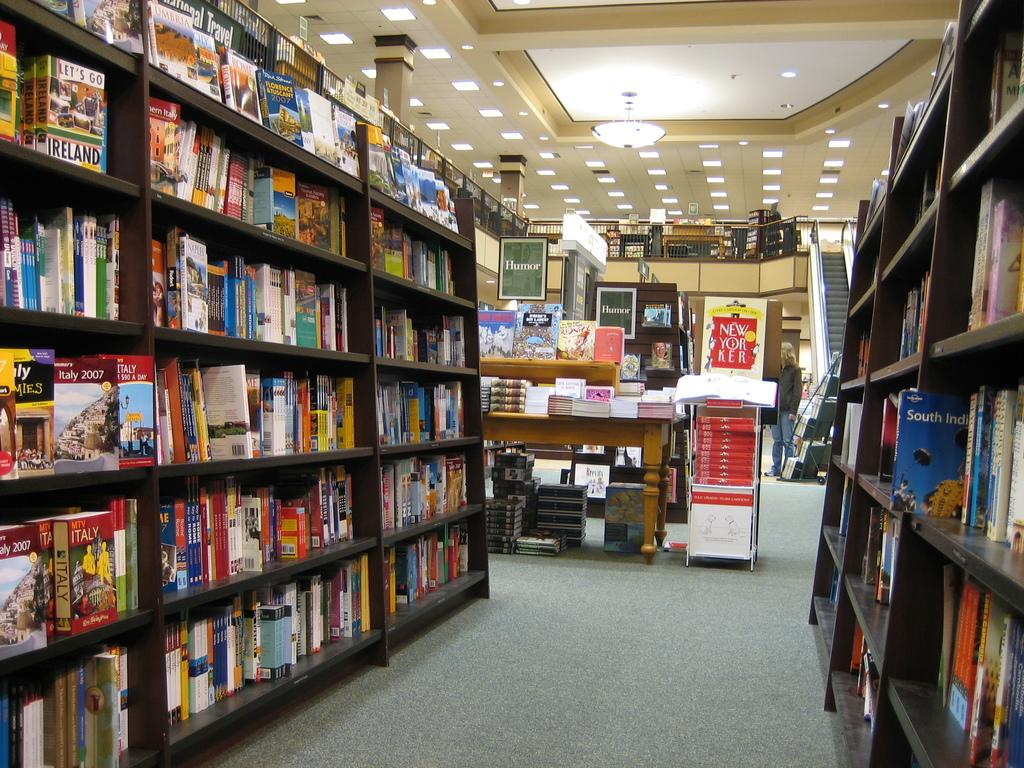<image>
Create a compact narrative representing the image presented. stacks of books in a book store interior for titles like Let's Go Ireland 